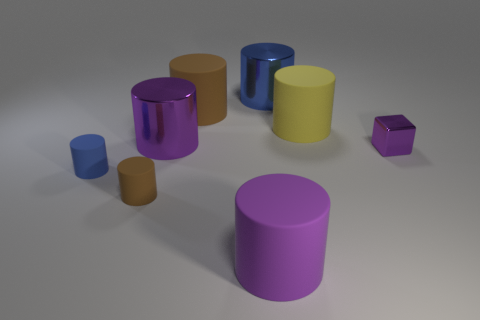Add 1 brown rubber cylinders. How many objects exist? 9 Subtract all blue metallic cylinders. How many cylinders are left? 6 Subtract 1 cubes. How many cubes are left? 0 Subtract all brown cylinders. How many cylinders are left? 5 Subtract all brown cylinders. Subtract all gray balls. How many cylinders are left? 5 Add 3 big blue cylinders. How many big blue cylinders exist? 4 Subtract 0 blue cubes. How many objects are left? 8 Subtract all blocks. How many objects are left? 7 Subtract all blue cubes. How many blue cylinders are left? 2 Subtract all blue rubber objects. Subtract all large purple metallic cylinders. How many objects are left? 6 